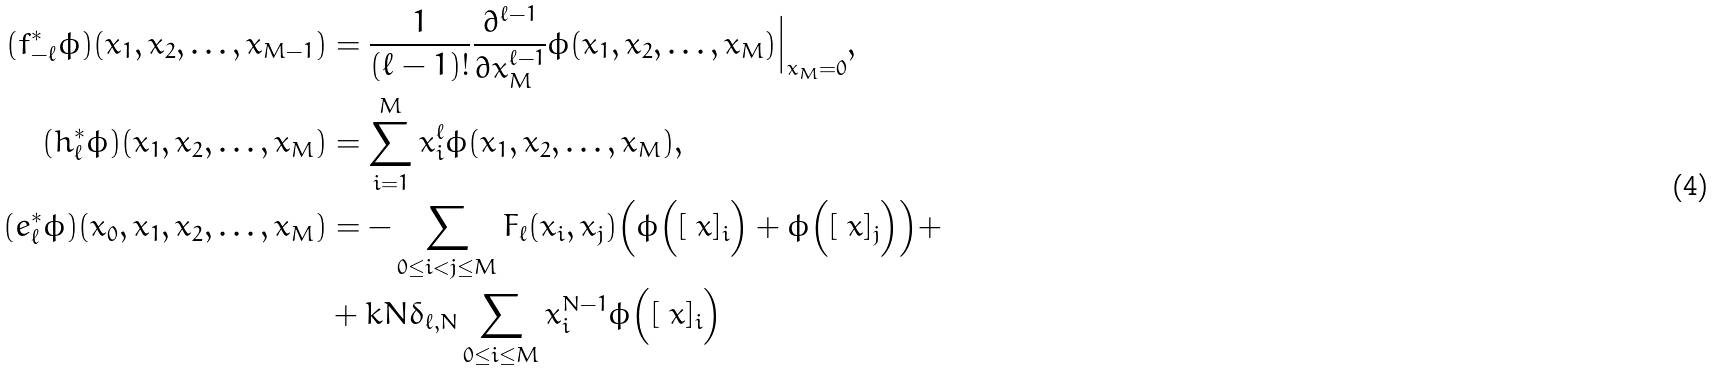Convert formula to latex. <formula><loc_0><loc_0><loc_500><loc_500>( f _ { - \ell } ^ { * } \phi ) ( x _ { 1 } , x _ { 2 } , \dots , x _ { M - 1 } ) & = \frac { 1 } { ( \ell - 1 ) ! } \frac { \partial ^ { \ell - 1 } } { \partial x _ { M } ^ { \ell - 1 } } \phi ( x _ { 1 } , x _ { 2 } , \dots , x _ { M } ) \Big | _ { x _ { M } = 0 } , \\ ( h _ { \ell } ^ { * } \phi ) ( x _ { 1 } , x _ { 2 } , \dots , x _ { M } ) & = \sum _ { i = 1 } ^ { M } x _ { i } ^ { \ell } \phi ( x _ { 1 } , x _ { 2 } , \dots , x _ { M } ) , \\ ( e _ { \ell } ^ { * } \phi ) ( x _ { 0 } , x _ { 1 } , x _ { 2 } , \dots , x _ { M } ) & = - \sum _ { 0 \leq i < j \leq M } F _ { \ell } ( x _ { i } , x _ { j } ) \Big ( \phi \Big ( [ \ x ] _ { i } \Big ) + \phi \Big ( [ \ x ] _ { j } \Big ) \Big ) + \\ & + k N \delta _ { \ell , N } \sum _ { 0 \leq i \leq M } x _ { i } ^ { N - 1 } \phi \Big ( [ \ x ] _ { i } \Big )</formula> 